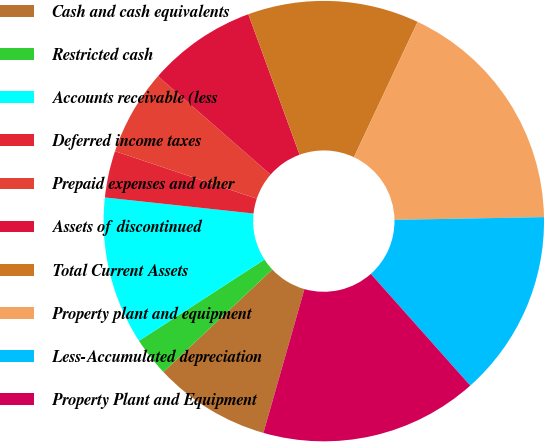Convert chart to OTSL. <chart><loc_0><loc_0><loc_500><loc_500><pie_chart><fcel>Cash and cash equivalents<fcel>Restricted cash<fcel>Accounts receivable (less<fcel>Deferred income taxes<fcel>Prepaid expenses and other<fcel>Assets of discontinued<fcel>Total Current Assets<fcel>Property plant and equipment<fcel>Less-Accumulated depreciation<fcel>Property Plant and Equipment<nl><fcel>8.57%<fcel>2.86%<fcel>10.86%<fcel>3.43%<fcel>6.29%<fcel>8.0%<fcel>12.57%<fcel>17.71%<fcel>13.71%<fcel>16.0%<nl></chart> 